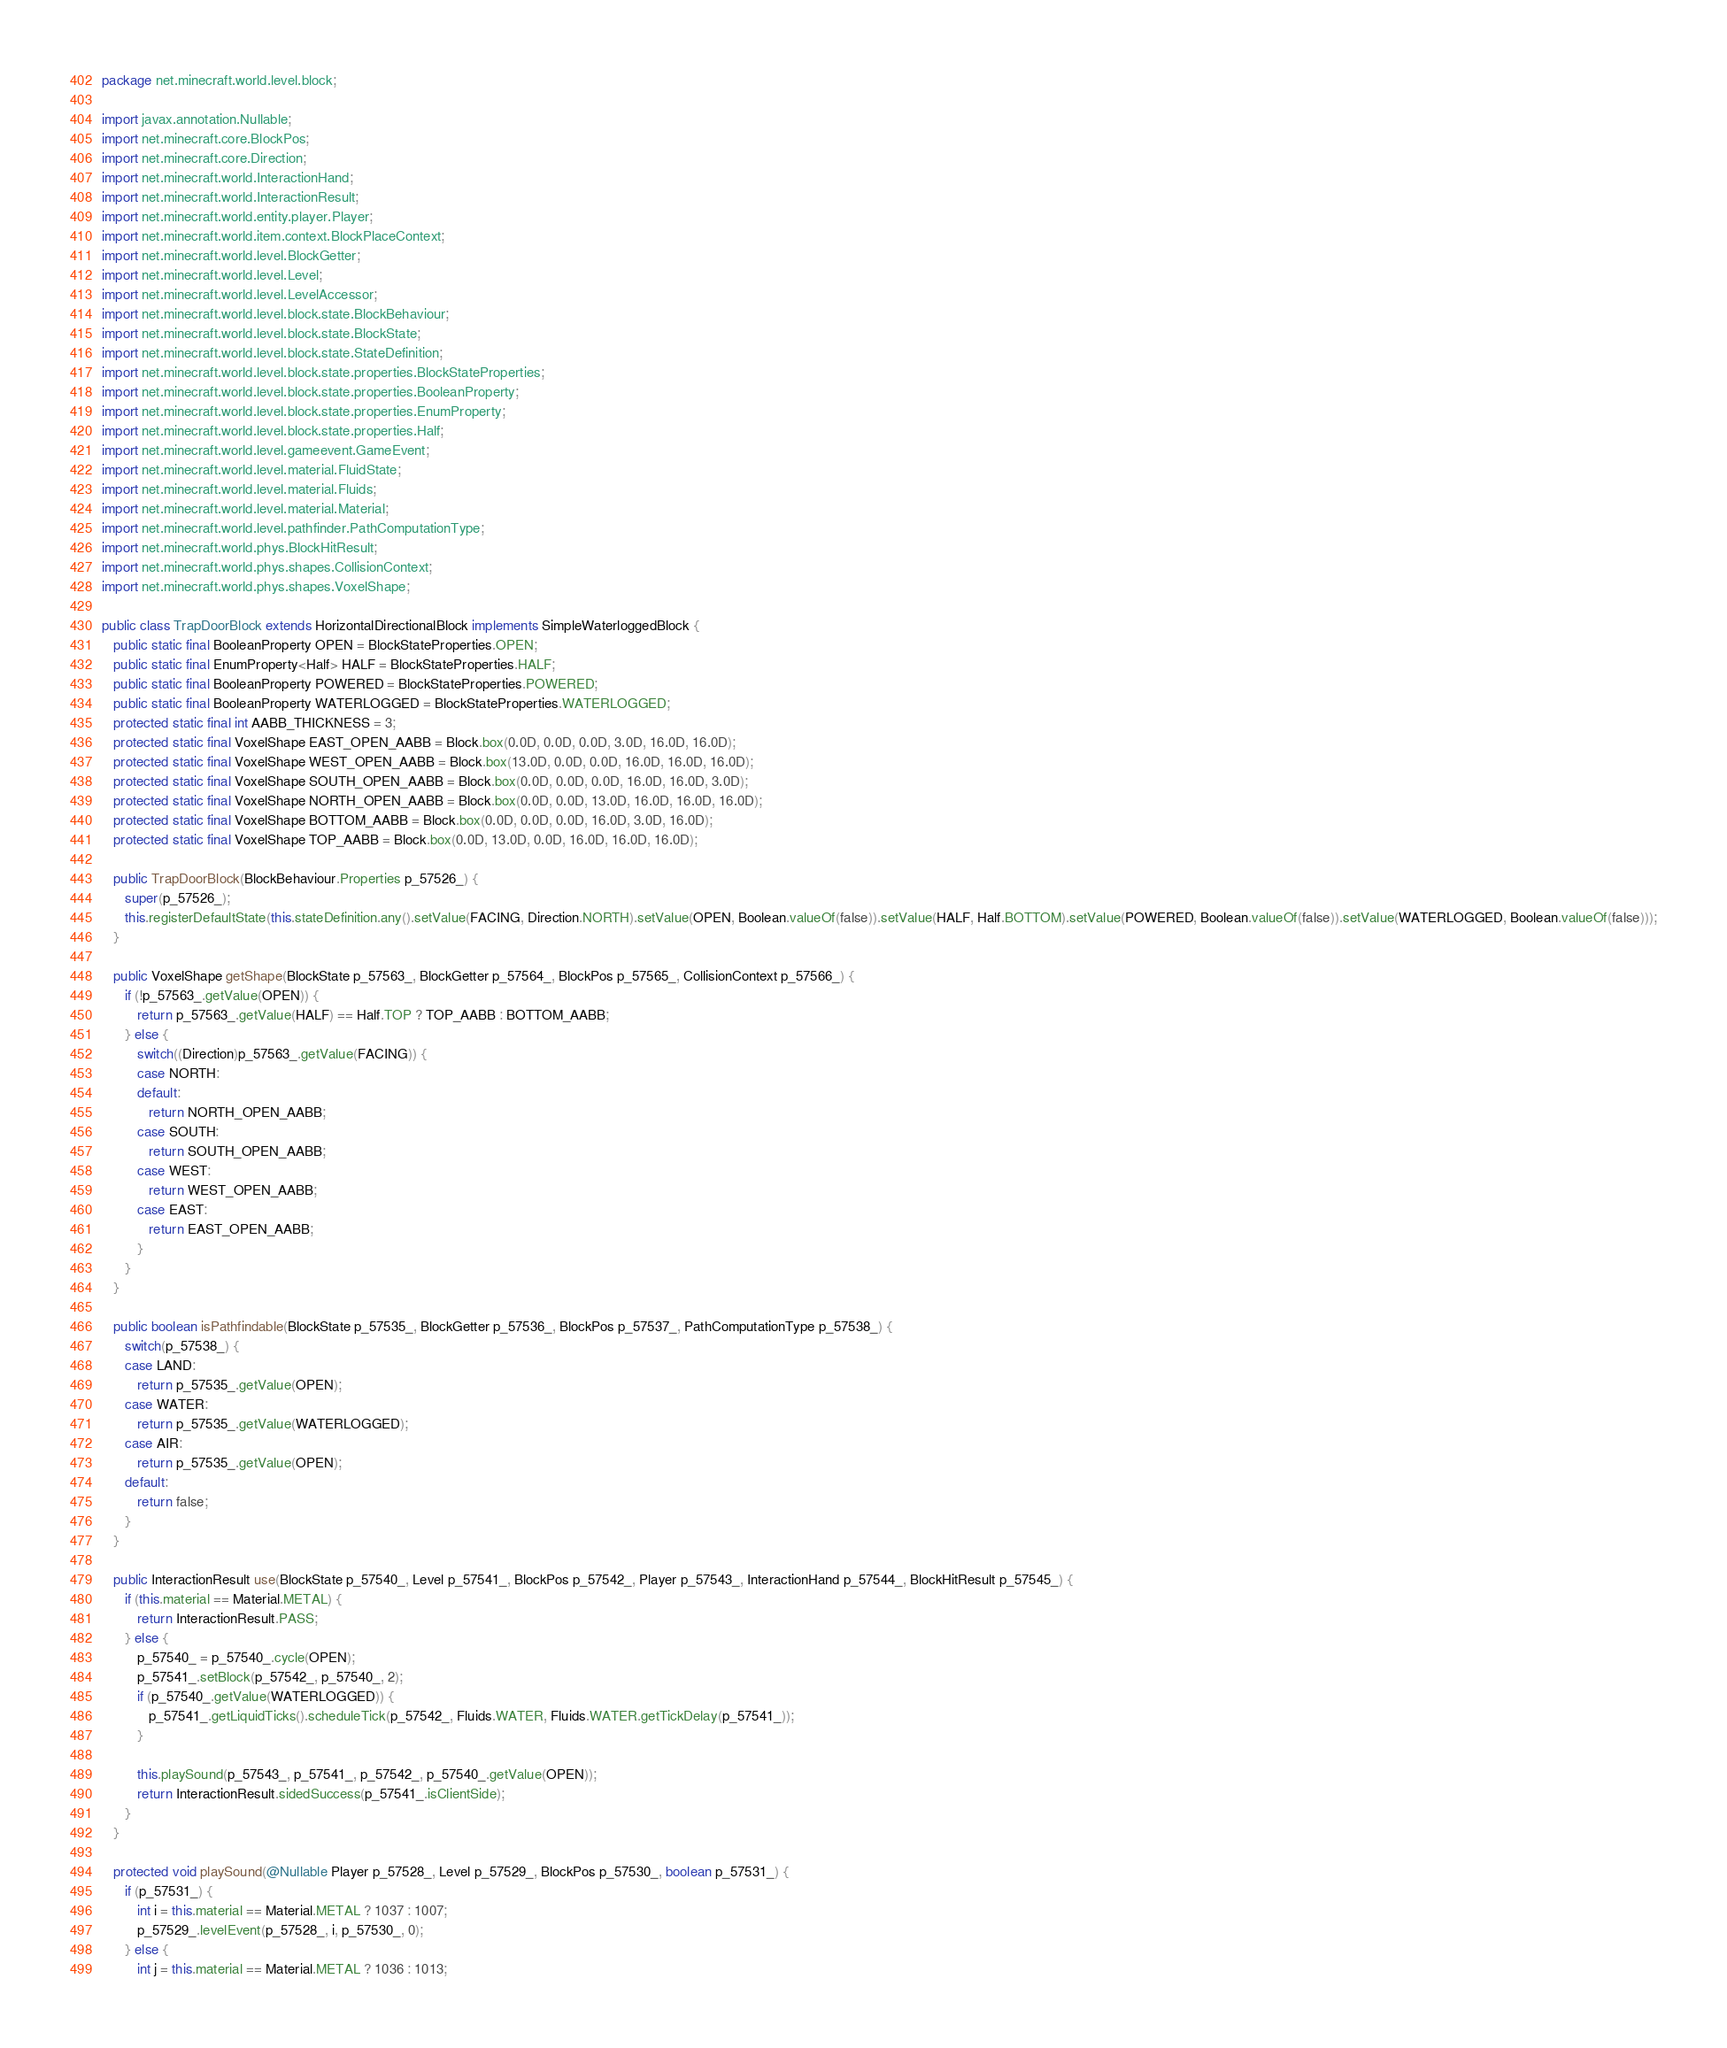<code> <loc_0><loc_0><loc_500><loc_500><_Java_>package net.minecraft.world.level.block;

import javax.annotation.Nullable;
import net.minecraft.core.BlockPos;
import net.minecraft.core.Direction;
import net.minecraft.world.InteractionHand;
import net.minecraft.world.InteractionResult;
import net.minecraft.world.entity.player.Player;
import net.minecraft.world.item.context.BlockPlaceContext;
import net.minecraft.world.level.BlockGetter;
import net.minecraft.world.level.Level;
import net.minecraft.world.level.LevelAccessor;
import net.minecraft.world.level.block.state.BlockBehaviour;
import net.minecraft.world.level.block.state.BlockState;
import net.minecraft.world.level.block.state.StateDefinition;
import net.minecraft.world.level.block.state.properties.BlockStateProperties;
import net.minecraft.world.level.block.state.properties.BooleanProperty;
import net.minecraft.world.level.block.state.properties.EnumProperty;
import net.minecraft.world.level.block.state.properties.Half;
import net.minecraft.world.level.gameevent.GameEvent;
import net.minecraft.world.level.material.FluidState;
import net.minecraft.world.level.material.Fluids;
import net.minecraft.world.level.material.Material;
import net.minecraft.world.level.pathfinder.PathComputationType;
import net.minecraft.world.phys.BlockHitResult;
import net.minecraft.world.phys.shapes.CollisionContext;
import net.minecraft.world.phys.shapes.VoxelShape;

public class TrapDoorBlock extends HorizontalDirectionalBlock implements SimpleWaterloggedBlock {
   public static final BooleanProperty OPEN = BlockStateProperties.OPEN;
   public static final EnumProperty<Half> HALF = BlockStateProperties.HALF;
   public static final BooleanProperty POWERED = BlockStateProperties.POWERED;
   public static final BooleanProperty WATERLOGGED = BlockStateProperties.WATERLOGGED;
   protected static final int AABB_THICKNESS = 3;
   protected static final VoxelShape EAST_OPEN_AABB = Block.box(0.0D, 0.0D, 0.0D, 3.0D, 16.0D, 16.0D);
   protected static final VoxelShape WEST_OPEN_AABB = Block.box(13.0D, 0.0D, 0.0D, 16.0D, 16.0D, 16.0D);
   protected static final VoxelShape SOUTH_OPEN_AABB = Block.box(0.0D, 0.0D, 0.0D, 16.0D, 16.0D, 3.0D);
   protected static final VoxelShape NORTH_OPEN_AABB = Block.box(0.0D, 0.0D, 13.0D, 16.0D, 16.0D, 16.0D);
   protected static final VoxelShape BOTTOM_AABB = Block.box(0.0D, 0.0D, 0.0D, 16.0D, 3.0D, 16.0D);
   protected static final VoxelShape TOP_AABB = Block.box(0.0D, 13.0D, 0.0D, 16.0D, 16.0D, 16.0D);

   public TrapDoorBlock(BlockBehaviour.Properties p_57526_) {
      super(p_57526_);
      this.registerDefaultState(this.stateDefinition.any().setValue(FACING, Direction.NORTH).setValue(OPEN, Boolean.valueOf(false)).setValue(HALF, Half.BOTTOM).setValue(POWERED, Boolean.valueOf(false)).setValue(WATERLOGGED, Boolean.valueOf(false)));
   }

   public VoxelShape getShape(BlockState p_57563_, BlockGetter p_57564_, BlockPos p_57565_, CollisionContext p_57566_) {
      if (!p_57563_.getValue(OPEN)) {
         return p_57563_.getValue(HALF) == Half.TOP ? TOP_AABB : BOTTOM_AABB;
      } else {
         switch((Direction)p_57563_.getValue(FACING)) {
         case NORTH:
         default:
            return NORTH_OPEN_AABB;
         case SOUTH:
            return SOUTH_OPEN_AABB;
         case WEST:
            return WEST_OPEN_AABB;
         case EAST:
            return EAST_OPEN_AABB;
         }
      }
   }

   public boolean isPathfindable(BlockState p_57535_, BlockGetter p_57536_, BlockPos p_57537_, PathComputationType p_57538_) {
      switch(p_57538_) {
      case LAND:
         return p_57535_.getValue(OPEN);
      case WATER:
         return p_57535_.getValue(WATERLOGGED);
      case AIR:
         return p_57535_.getValue(OPEN);
      default:
         return false;
      }
   }

   public InteractionResult use(BlockState p_57540_, Level p_57541_, BlockPos p_57542_, Player p_57543_, InteractionHand p_57544_, BlockHitResult p_57545_) {
      if (this.material == Material.METAL) {
         return InteractionResult.PASS;
      } else {
         p_57540_ = p_57540_.cycle(OPEN);
         p_57541_.setBlock(p_57542_, p_57540_, 2);
         if (p_57540_.getValue(WATERLOGGED)) {
            p_57541_.getLiquidTicks().scheduleTick(p_57542_, Fluids.WATER, Fluids.WATER.getTickDelay(p_57541_));
         }

         this.playSound(p_57543_, p_57541_, p_57542_, p_57540_.getValue(OPEN));
         return InteractionResult.sidedSuccess(p_57541_.isClientSide);
      }
   }

   protected void playSound(@Nullable Player p_57528_, Level p_57529_, BlockPos p_57530_, boolean p_57531_) {
      if (p_57531_) {
         int i = this.material == Material.METAL ? 1037 : 1007;
         p_57529_.levelEvent(p_57528_, i, p_57530_, 0);
      } else {
         int j = this.material == Material.METAL ? 1036 : 1013;</code> 